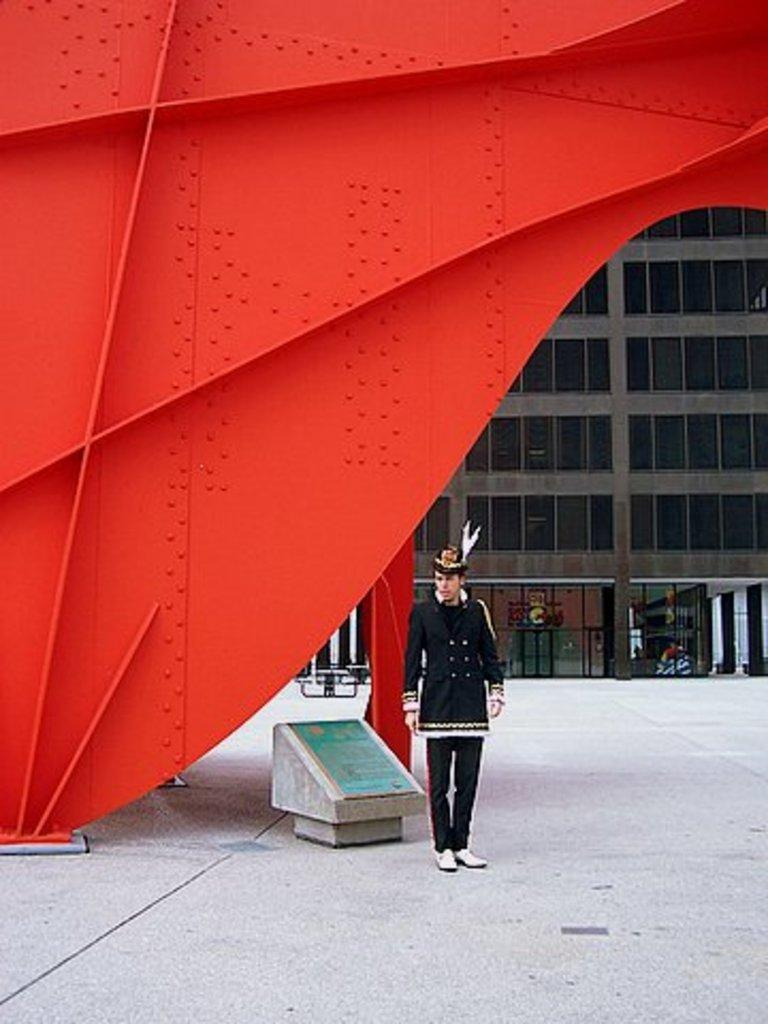What is the person in the image standing beside? The person is standing beside a wooden board in the image. Can you describe the red object in the image? The red object resembles an iron wall in the image. What can be seen in the background of the image? There is a building in the background of the image. What direction is the person's heart facing in the image? There is no indication of the person's heart in the image, so it cannot be determined which direction it might be facing. 